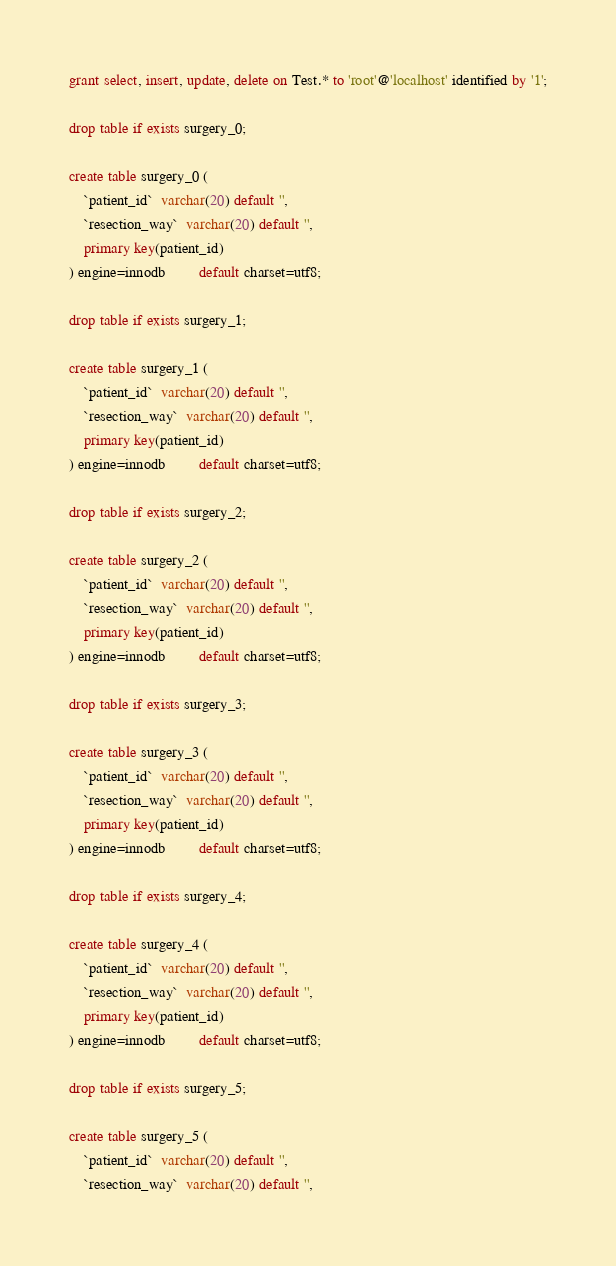<code> <loc_0><loc_0><loc_500><loc_500><_SQL_>
grant select, insert, update, delete on Test.* to 'root'@'localhost' identified by '1';

drop table if exists surgery_0;

create table surgery_0 (
    `patient_id`  varchar(20) default '',
    `resection_way`  varchar(20) default '',
    primary key(patient_id)
) engine=innodb         default charset=utf8;

drop table if exists surgery_1;

create table surgery_1 (
    `patient_id`  varchar(20) default '',
    `resection_way`  varchar(20) default '',
    primary key(patient_id)
) engine=innodb         default charset=utf8;

drop table if exists surgery_2;

create table surgery_2 (
    `patient_id`  varchar(20) default '',
    `resection_way`  varchar(20) default '',
    primary key(patient_id)
) engine=innodb         default charset=utf8;

drop table if exists surgery_3;

create table surgery_3 (
    `patient_id`  varchar(20) default '',
    `resection_way`  varchar(20) default '',
    primary key(patient_id)
) engine=innodb         default charset=utf8;

drop table if exists surgery_4;

create table surgery_4 (
    `patient_id`  varchar(20) default '',
    `resection_way`  varchar(20) default '',
    primary key(patient_id)
) engine=innodb         default charset=utf8;

drop table if exists surgery_5;

create table surgery_5 (
    `patient_id`  varchar(20) default '',
    `resection_way`  varchar(20) default '',</code> 